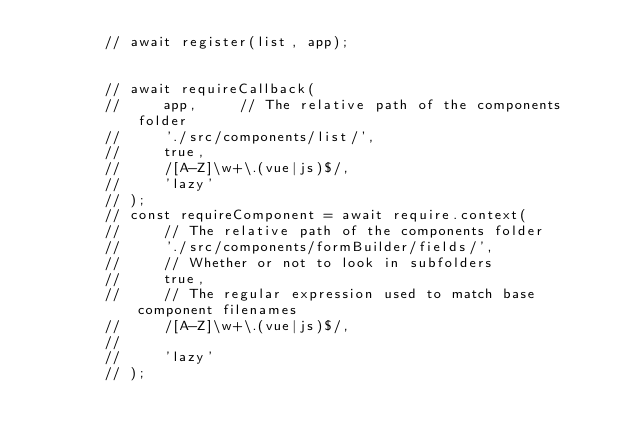<code> <loc_0><loc_0><loc_500><loc_500><_JavaScript_>        // await register(list, app);


        // await requireCallback(
        //     app,     // The relative path of the components folder
        //     './src/components/list/',
        //     true,
        //     /[A-Z]\w+\.(vue|js)$/,
        //     'lazy'
        // );
        // const requireComponent = await require.context(
        //     // The relative path of the components folder
        //     './src/components/formBuilder/fields/',
        //     // Whether or not to look in subfolders
        //     true,
        //     // The regular expression used to match base component filenames
        //     /[A-Z]\w+\.(vue|js)$/,
        //
        //     'lazy'
        // );</code> 